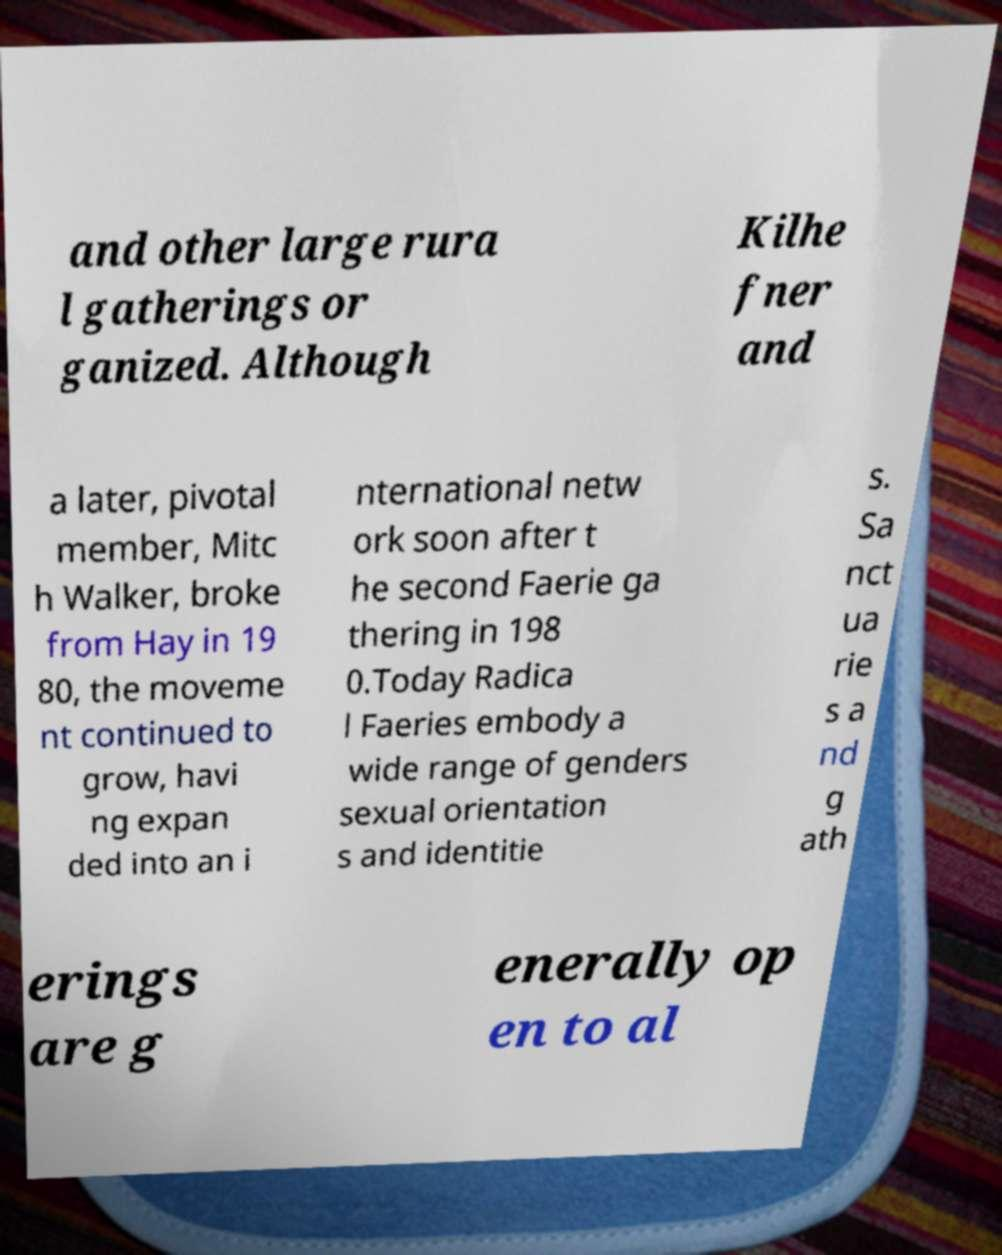For documentation purposes, I need the text within this image transcribed. Could you provide that? and other large rura l gatherings or ganized. Although Kilhe fner and a later, pivotal member, Mitc h Walker, broke from Hay in 19 80, the moveme nt continued to grow, havi ng expan ded into an i nternational netw ork soon after t he second Faerie ga thering in 198 0.Today Radica l Faeries embody a wide range of genders sexual orientation s and identitie s. Sa nct ua rie s a nd g ath erings are g enerally op en to al 